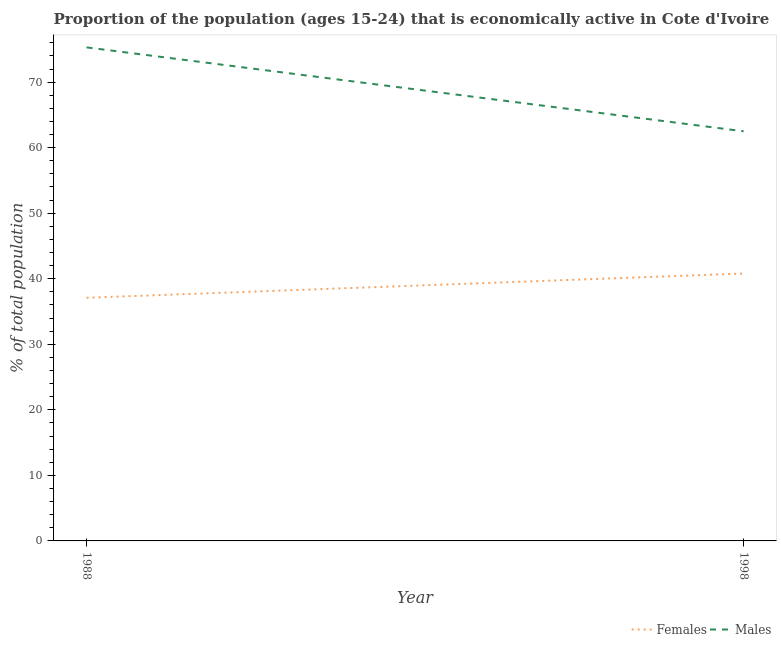Is the number of lines equal to the number of legend labels?
Your response must be concise. Yes. What is the percentage of economically active male population in 1998?
Provide a short and direct response. 62.5. Across all years, what is the maximum percentage of economically active female population?
Provide a succinct answer. 40.8. Across all years, what is the minimum percentage of economically active female population?
Keep it short and to the point. 37.1. In which year was the percentage of economically active male population minimum?
Keep it short and to the point. 1998. What is the total percentage of economically active female population in the graph?
Give a very brief answer. 77.9. What is the difference between the percentage of economically active female population in 1988 and that in 1998?
Offer a very short reply. -3.7. What is the difference between the percentage of economically active male population in 1988 and the percentage of economically active female population in 1998?
Offer a very short reply. 34.5. What is the average percentage of economically active male population per year?
Offer a very short reply. 68.9. In the year 1998, what is the difference between the percentage of economically active female population and percentage of economically active male population?
Your answer should be compact. -21.7. What is the ratio of the percentage of economically active male population in 1988 to that in 1998?
Offer a very short reply. 1.2. In how many years, is the percentage of economically active male population greater than the average percentage of economically active male population taken over all years?
Your answer should be compact. 1. How many lines are there?
Offer a very short reply. 2. How many years are there in the graph?
Give a very brief answer. 2. Are the values on the major ticks of Y-axis written in scientific E-notation?
Provide a succinct answer. No. Does the graph contain any zero values?
Offer a terse response. No. Where does the legend appear in the graph?
Offer a very short reply. Bottom right. How many legend labels are there?
Make the answer very short. 2. How are the legend labels stacked?
Offer a terse response. Horizontal. What is the title of the graph?
Give a very brief answer. Proportion of the population (ages 15-24) that is economically active in Cote d'Ivoire. Does "Long-term debt" appear as one of the legend labels in the graph?
Your answer should be compact. No. What is the label or title of the X-axis?
Offer a very short reply. Year. What is the label or title of the Y-axis?
Offer a very short reply. % of total population. What is the % of total population of Females in 1988?
Your response must be concise. 37.1. What is the % of total population in Males in 1988?
Your answer should be very brief. 75.3. What is the % of total population in Females in 1998?
Your answer should be compact. 40.8. What is the % of total population in Males in 1998?
Offer a very short reply. 62.5. Across all years, what is the maximum % of total population of Females?
Offer a terse response. 40.8. Across all years, what is the maximum % of total population in Males?
Your answer should be compact. 75.3. Across all years, what is the minimum % of total population of Females?
Offer a terse response. 37.1. Across all years, what is the minimum % of total population of Males?
Provide a short and direct response. 62.5. What is the total % of total population of Females in the graph?
Ensure brevity in your answer.  77.9. What is the total % of total population in Males in the graph?
Your response must be concise. 137.8. What is the difference between the % of total population of Females in 1988 and that in 1998?
Offer a very short reply. -3.7. What is the difference between the % of total population in Males in 1988 and that in 1998?
Provide a succinct answer. 12.8. What is the difference between the % of total population of Females in 1988 and the % of total population of Males in 1998?
Give a very brief answer. -25.4. What is the average % of total population of Females per year?
Give a very brief answer. 38.95. What is the average % of total population of Males per year?
Your answer should be compact. 68.9. In the year 1988, what is the difference between the % of total population in Females and % of total population in Males?
Your answer should be very brief. -38.2. In the year 1998, what is the difference between the % of total population of Females and % of total population of Males?
Give a very brief answer. -21.7. What is the ratio of the % of total population of Females in 1988 to that in 1998?
Ensure brevity in your answer.  0.91. What is the ratio of the % of total population of Males in 1988 to that in 1998?
Your answer should be compact. 1.2. What is the difference between the highest and the second highest % of total population in Females?
Provide a short and direct response. 3.7. What is the difference between the highest and the second highest % of total population of Males?
Ensure brevity in your answer.  12.8. What is the difference between the highest and the lowest % of total population in Females?
Ensure brevity in your answer.  3.7. What is the difference between the highest and the lowest % of total population of Males?
Provide a short and direct response. 12.8. 